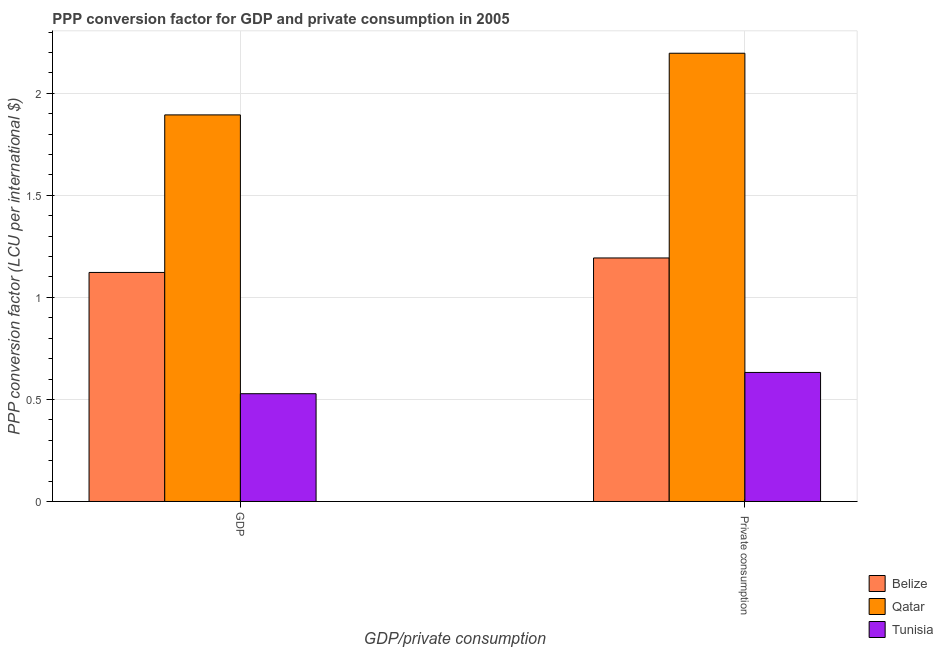How many groups of bars are there?
Your response must be concise. 2. Are the number of bars per tick equal to the number of legend labels?
Your response must be concise. Yes. What is the label of the 1st group of bars from the left?
Offer a terse response. GDP. What is the ppp conversion factor for private consumption in Belize?
Offer a terse response. 1.19. Across all countries, what is the maximum ppp conversion factor for gdp?
Give a very brief answer. 1.89. Across all countries, what is the minimum ppp conversion factor for gdp?
Provide a succinct answer. 0.53. In which country was the ppp conversion factor for private consumption maximum?
Keep it short and to the point. Qatar. In which country was the ppp conversion factor for private consumption minimum?
Give a very brief answer. Tunisia. What is the total ppp conversion factor for private consumption in the graph?
Provide a short and direct response. 4.02. What is the difference between the ppp conversion factor for gdp in Qatar and that in Tunisia?
Offer a very short reply. 1.37. What is the difference between the ppp conversion factor for private consumption in Belize and the ppp conversion factor for gdp in Tunisia?
Provide a short and direct response. 0.67. What is the average ppp conversion factor for private consumption per country?
Ensure brevity in your answer.  1.34. What is the difference between the ppp conversion factor for private consumption and ppp conversion factor for gdp in Belize?
Provide a succinct answer. 0.07. In how many countries, is the ppp conversion factor for gdp greater than 1.3 LCU?
Your response must be concise. 1. What is the ratio of the ppp conversion factor for gdp in Belize to that in Tunisia?
Your answer should be compact. 2.13. Is the ppp conversion factor for private consumption in Tunisia less than that in Belize?
Your answer should be compact. Yes. What does the 2nd bar from the left in GDP represents?
Keep it short and to the point. Qatar. What does the 3rd bar from the right in  Private consumption represents?
Offer a terse response. Belize. Are the values on the major ticks of Y-axis written in scientific E-notation?
Offer a terse response. No. Does the graph contain any zero values?
Give a very brief answer. No. Does the graph contain grids?
Provide a short and direct response. Yes. What is the title of the graph?
Provide a short and direct response. PPP conversion factor for GDP and private consumption in 2005. Does "Barbados" appear as one of the legend labels in the graph?
Provide a short and direct response. No. What is the label or title of the X-axis?
Provide a succinct answer. GDP/private consumption. What is the label or title of the Y-axis?
Give a very brief answer. PPP conversion factor (LCU per international $). What is the PPP conversion factor (LCU per international $) of Belize in GDP?
Keep it short and to the point. 1.12. What is the PPP conversion factor (LCU per international $) in Qatar in GDP?
Provide a short and direct response. 1.89. What is the PPP conversion factor (LCU per international $) of Tunisia in GDP?
Your answer should be very brief. 0.53. What is the PPP conversion factor (LCU per international $) in Belize in  Private consumption?
Ensure brevity in your answer.  1.19. What is the PPP conversion factor (LCU per international $) in Qatar in  Private consumption?
Your response must be concise. 2.2. What is the PPP conversion factor (LCU per international $) of Tunisia in  Private consumption?
Make the answer very short. 0.63. Across all GDP/private consumption, what is the maximum PPP conversion factor (LCU per international $) of Belize?
Provide a short and direct response. 1.19. Across all GDP/private consumption, what is the maximum PPP conversion factor (LCU per international $) in Qatar?
Your response must be concise. 2.2. Across all GDP/private consumption, what is the maximum PPP conversion factor (LCU per international $) in Tunisia?
Provide a short and direct response. 0.63. Across all GDP/private consumption, what is the minimum PPP conversion factor (LCU per international $) of Belize?
Your answer should be very brief. 1.12. Across all GDP/private consumption, what is the minimum PPP conversion factor (LCU per international $) of Qatar?
Offer a very short reply. 1.89. Across all GDP/private consumption, what is the minimum PPP conversion factor (LCU per international $) of Tunisia?
Provide a short and direct response. 0.53. What is the total PPP conversion factor (LCU per international $) in Belize in the graph?
Make the answer very short. 2.32. What is the total PPP conversion factor (LCU per international $) in Qatar in the graph?
Ensure brevity in your answer.  4.09. What is the total PPP conversion factor (LCU per international $) of Tunisia in the graph?
Give a very brief answer. 1.16. What is the difference between the PPP conversion factor (LCU per international $) of Belize in GDP and that in  Private consumption?
Your response must be concise. -0.07. What is the difference between the PPP conversion factor (LCU per international $) in Qatar in GDP and that in  Private consumption?
Your answer should be very brief. -0.3. What is the difference between the PPP conversion factor (LCU per international $) in Tunisia in GDP and that in  Private consumption?
Give a very brief answer. -0.1. What is the difference between the PPP conversion factor (LCU per international $) of Belize in GDP and the PPP conversion factor (LCU per international $) of Qatar in  Private consumption?
Keep it short and to the point. -1.07. What is the difference between the PPP conversion factor (LCU per international $) in Belize in GDP and the PPP conversion factor (LCU per international $) in Tunisia in  Private consumption?
Your answer should be compact. 0.49. What is the difference between the PPP conversion factor (LCU per international $) of Qatar in GDP and the PPP conversion factor (LCU per international $) of Tunisia in  Private consumption?
Give a very brief answer. 1.26. What is the average PPP conversion factor (LCU per international $) of Belize per GDP/private consumption?
Your answer should be compact. 1.16. What is the average PPP conversion factor (LCU per international $) in Qatar per GDP/private consumption?
Keep it short and to the point. 2.05. What is the average PPP conversion factor (LCU per international $) in Tunisia per GDP/private consumption?
Provide a succinct answer. 0.58. What is the difference between the PPP conversion factor (LCU per international $) in Belize and PPP conversion factor (LCU per international $) in Qatar in GDP?
Offer a very short reply. -0.77. What is the difference between the PPP conversion factor (LCU per international $) in Belize and PPP conversion factor (LCU per international $) in Tunisia in GDP?
Give a very brief answer. 0.59. What is the difference between the PPP conversion factor (LCU per international $) in Qatar and PPP conversion factor (LCU per international $) in Tunisia in GDP?
Your answer should be compact. 1.37. What is the difference between the PPP conversion factor (LCU per international $) in Belize and PPP conversion factor (LCU per international $) in Qatar in  Private consumption?
Give a very brief answer. -1. What is the difference between the PPP conversion factor (LCU per international $) of Belize and PPP conversion factor (LCU per international $) of Tunisia in  Private consumption?
Offer a very short reply. 0.56. What is the difference between the PPP conversion factor (LCU per international $) of Qatar and PPP conversion factor (LCU per international $) of Tunisia in  Private consumption?
Provide a succinct answer. 1.56. What is the ratio of the PPP conversion factor (LCU per international $) in Belize in GDP to that in  Private consumption?
Make the answer very short. 0.94. What is the ratio of the PPP conversion factor (LCU per international $) of Qatar in GDP to that in  Private consumption?
Provide a succinct answer. 0.86. What is the ratio of the PPP conversion factor (LCU per international $) in Tunisia in GDP to that in  Private consumption?
Offer a terse response. 0.84. What is the difference between the highest and the second highest PPP conversion factor (LCU per international $) of Belize?
Offer a terse response. 0.07. What is the difference between the highest and the second highest PPP conversion factor (LCU per international $) in Qatar?
Make the answer very short. 0.3. What is the difference between the highest and the second highest PPP conversion factor (LCU per international $) in Tunisia?
Your answer should be compact. 0.1. What is the difference between the highest and the lowest PPP conversion factor (LCU per international $) of Belize?
Provide a short and direct response. 0.07. What is the difference between the highest and the lowest PPP conversion factor (LCU per international $) in Qatar?
Make the answer very short. 0.3. What is the difference between the highest and the lowest PPP conversion factor (LCU per international $) of Tunisia?
Give a very brief answer. 0.1. 